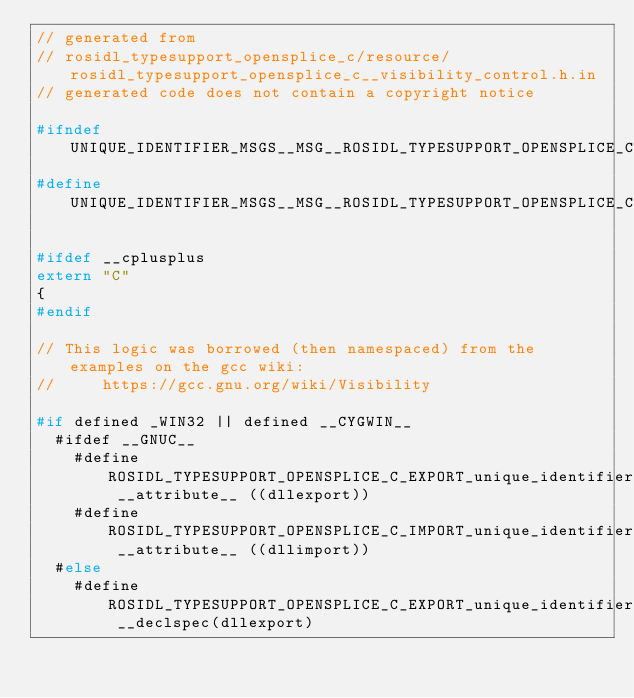<code> <loc_0><loc_0><loc_500><loc_500><_C_>// generated from
// rosidl_typesupport_opensplice_c/resource/rosidl_typesupport_opensplice_c__visibility_control.h.in
// generated code does not contain a copyright notice

#ifndef UNIQUE_IDENTIFIER_MSGS__MSG__ROSIDL_TYPESUPPORT_OPENSPLICE_C__VISIBILITY_CONTROL_H_
#define UNIQUE_IDENTIFIER_MSGS__MSG__ROSIDL_TYPESUPPORT_OPENSPLICE_C__VISIBILITY_CONTROL_H_

#ifdef __cplusplus
extern "C"
{
#endif

// This logic was borrowed (then namespaced) from the examples on the gcc wiki:
//     https://gcc.gnu.org/wiki/Visibility

#if defined _WIN32 || defined __CYGWIN__
  #ifdef __GNUC__
    #define ROSIDL_TYPESUPPORT_OPENSPLICE_C_EXPORT_unique_identifier_msgs __attribute__ ((dllexport))
    #define ROSIDL_TYPESUPPORT_OPENSPLICE_C_IMPORT_unique_identifier_msgs __attribute__ ((dllimport))
  #else
    #define ROSIDL_TYPESUPPORT_OPENSPLICE_C_EXPORT_unique_identifier_msgs __declspec(dllexport)</code> 